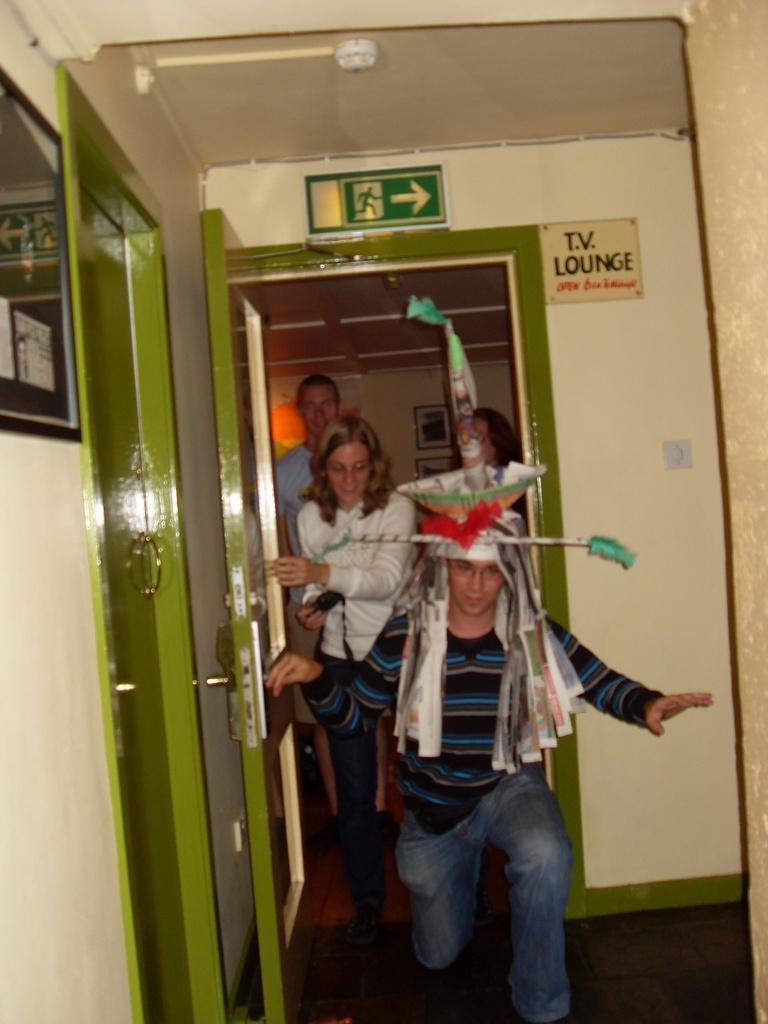Can you describe this image briefly? This image is taken in a room. In this image we can see some persons on the floor. We can also see the green color doors, a mirror, sign board, text board and also the frames attached to the plain wall. Ceiling is also visible in this image. 